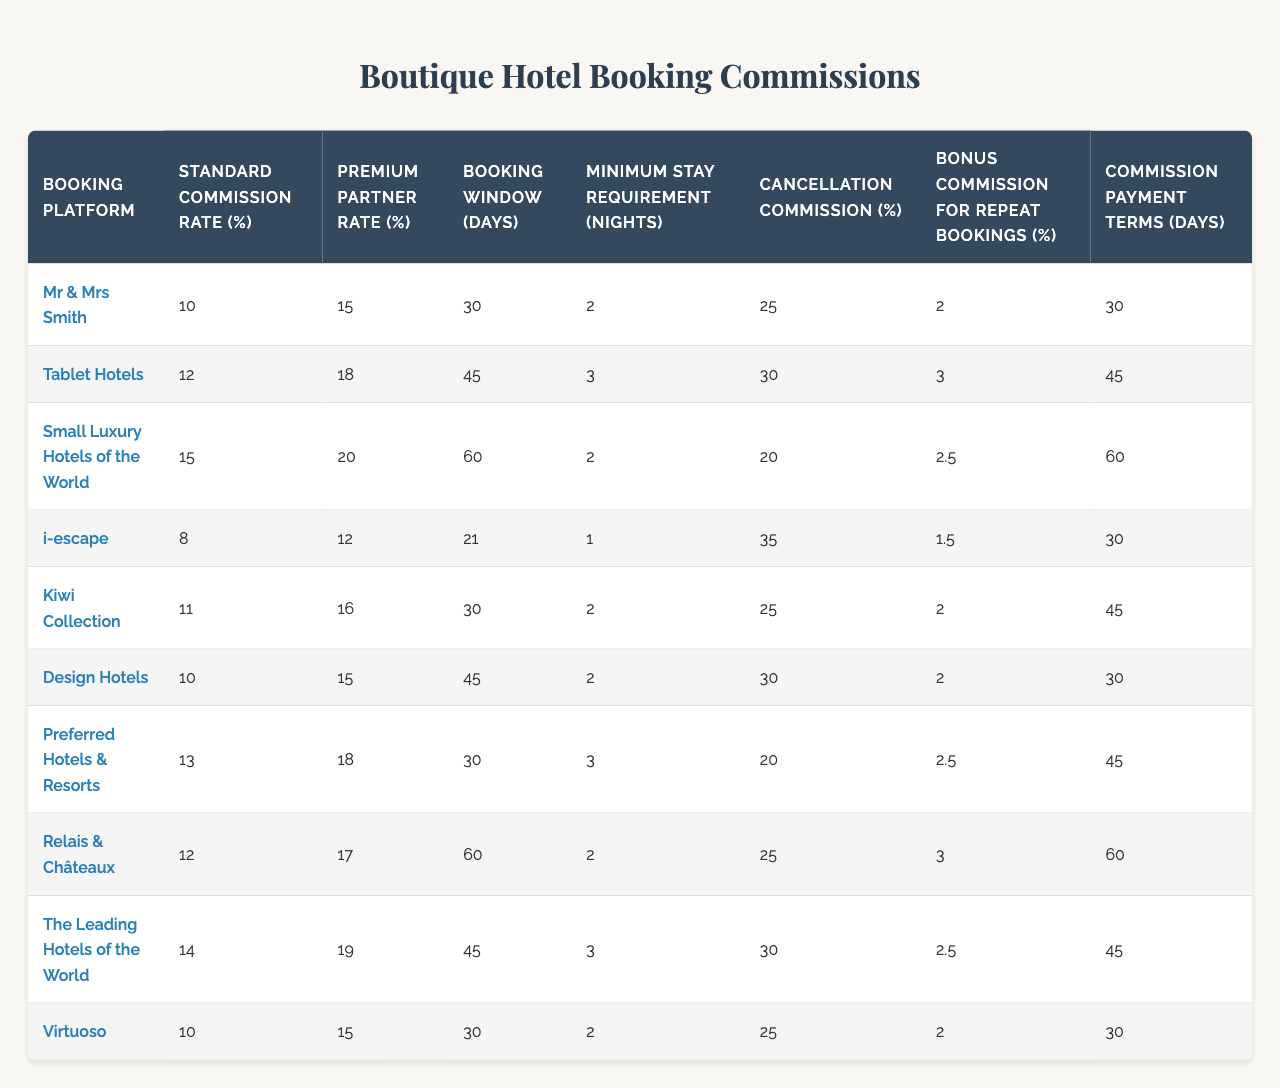What is the standard commission rate for i-escape? The standard commission rate for i-escape is listed in the table as 8%.
Answer: 8% Which booking platform has the highest premium partner rate? By examining the "Premium Partner Rate (%)" column, Relais & Châteaux has the highest premium partner rate at 17%.
Answer: 17% How many booking platforms require a minimum stay of 3 nights? The table shows that the platforms requiring a minimum stay of 3 nights are Tablet Hotels, Preferred Hotels & Resorts, and The Leading Hotels of the World, totaling 3.
Answer: 3 What is the average standard commission rate for all platforms? Summing the standard commission rates: (10 + 12 + 15 + 8 + 11 + 10 + 13 + 12 + 14 + 10) =  121; Dividing by 10 (the number of platforms) gives an average of 12.1%.
Answer: 12.1% Is it true that all platforms have a cancellation commission rate of at least 20%? Evaluating the "Cancellation Commission (%)" column, we see that i-escape has a cancellation commission of 35%, but the other platforms do fall below 20%, which means the statement is false.
Answer: No What is the difference between the highest and lowest bonus commission for repeat bookings? The highest bonus commission is 3% for Relais & Châteaux, and the lowest is 1.5% for i-escape. The difference is calculated as 3% - 1.5% = 1.5%.
Answer: 1.5% On which platform do agents receive the longest commission payment terms? The booking platform with the longest commission payment terms is Tablet Hotels, which is 45 days.
Answer: 45 days How does the standard commission rate for Relais & Châteaux compare to that of The Leading Hotels of the World? Relais & Châteaux has a standard commission rate of 12%, while The Leading Hotels of the World has a rate of 14%. Thus, The Leading Hotels of the World has a higher rate by 2%.
Answer: 2% What percentage of boutique hotel bookings does Virtuoso offer as a commission for repeat bookings? According to the table, Virtuoso offers a 2% bonus commission for repeat bookings.
Answer: 2% How many platforms have both a standard commission rate and a premium partner rate of at least 15%? By analyzing the table, Small Luxury Hotels of the World, Kiwi Collection, Design Hotels, Preferred Hotels & Resorts, Relais & Châteaux, and The Leading Hotels of the World meet this criteria, totaling 6 platforms.
Answer: 6 What is the highest minimum stay requirement among the listed platforms? The highest minimum stay requirement is found at Tablet Hotels and Preferred Hotels & Resorts, both requiring 3 nights.
Answer: 3 nights 